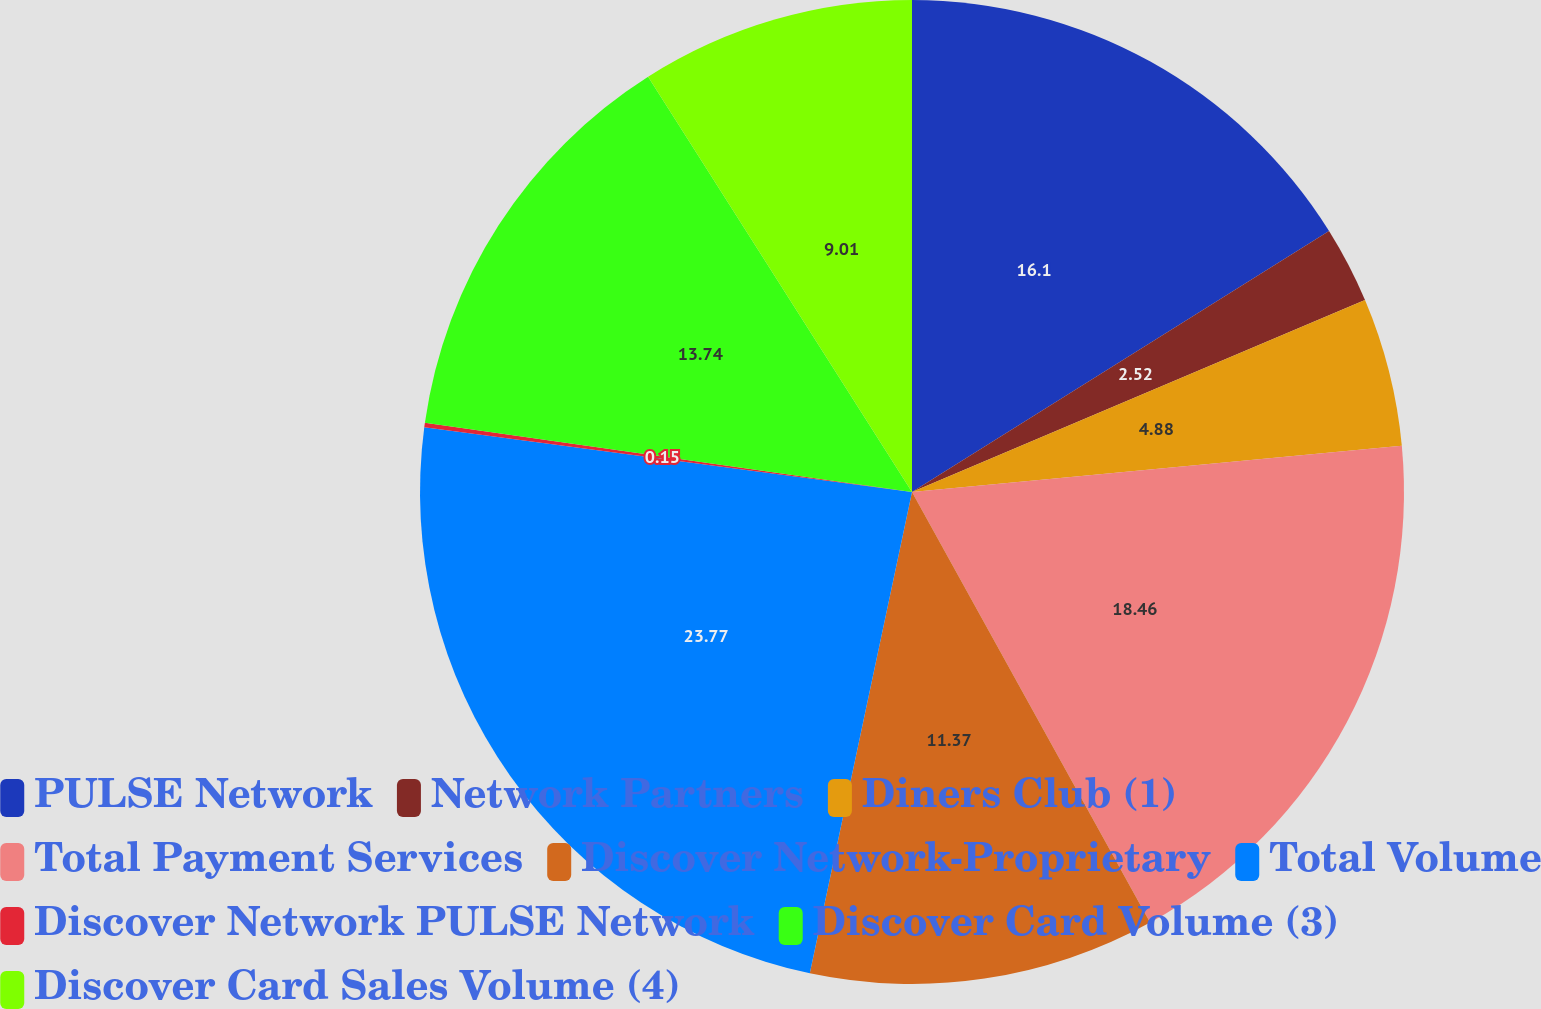Convert chart to OTSL. <chart><loc_0><loc_0><loc_500><loc_500><pie_chart><fcel>PULSE Network<fcel>Network Partners<fcel>Diners Club (1)<fcel>Total Payment Services<fcel>Discover Network-Proprietary<fcel>Total Volume<fcel>Discover Network PULSE Network<fcel>Discover Card Volume (3)<fcel>Discover Card Sales Volume (4)<nl><fcel>16.1%<fcel>2.52%<fcel>4.88%<fcel>18.46%<fcel>11.37%<fcel>23.77%<fcel>0.15%<fcel>13.74%<fcel>9.01%<nl></chart> 